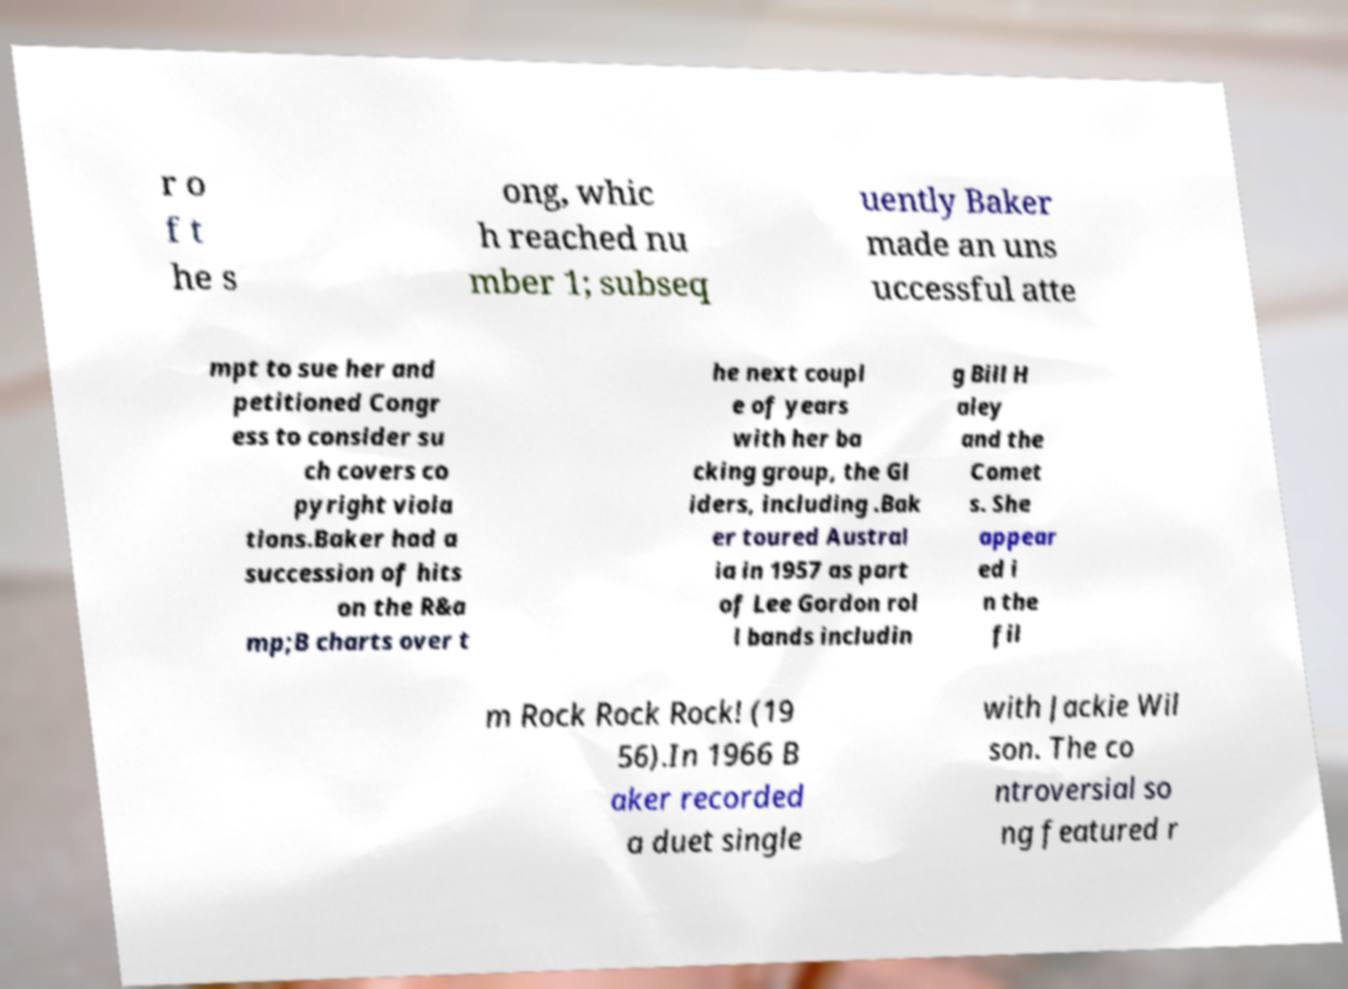Could you extract and type out the text from this image? r o f t he s ong, whic h reached nu mber 1; subseq uently Baker made an uns uccessful atte mpt to sue her and petitioned Congr ess to consider su ch covers co pyright viola tions.Baker had a succession of hits on the R&a mp;B charts over t he next coupl e of years with her ba cking group, the Gl iders, including .Bak er toured Austral ia in 1957 as part of Lee Gordon rol l bands includin g Bill H aley and the Comet s. She appear ed i n the fil m Rock Rock Rock! (19 56).In 1966 B aker recorded a duet single with Jackie Wil son. The co ntroversial so ng featured r 